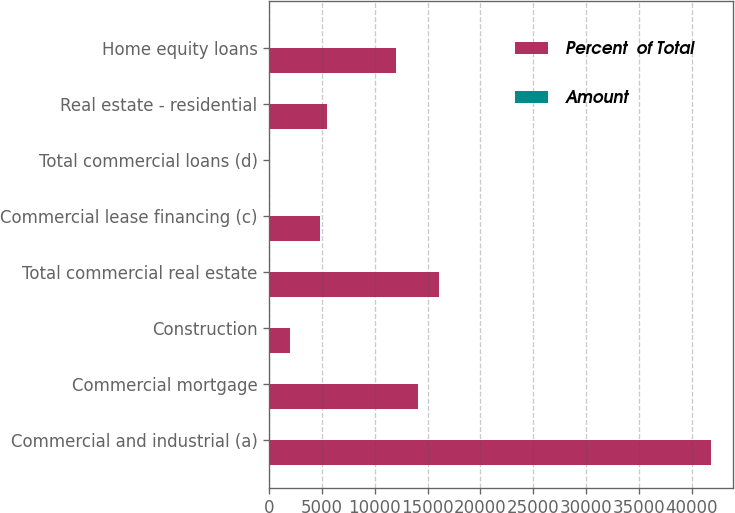Convert chart. <chart><loc_0><loc_0><loc_500><loc_500><stacked_bar_chart><ecel><fcel>Commercial and industrial (a)<fcel>Commercial mortgage<fcel>Construction<fcel>Total commercial real estate<fcel>Commercial lease financing (c)<fcel>Total commercial loans (d)<fcel>Real estate - residential<fcel>Home equity loans<nl><fcel>Percent  of Total<fcel>41859<fcel>14088<fcel>1960<fcel>16048<fcel>4826<fcel>72.6<fcel>5483<fcel>12028<nl><fcel>Amount<fcel>48.4<fcel>16.3<fcel>2.3<fcel>18.6<fcel>5.6<fcel>72.6<fcel>6.3<fcel>13.9<nl></chart> 